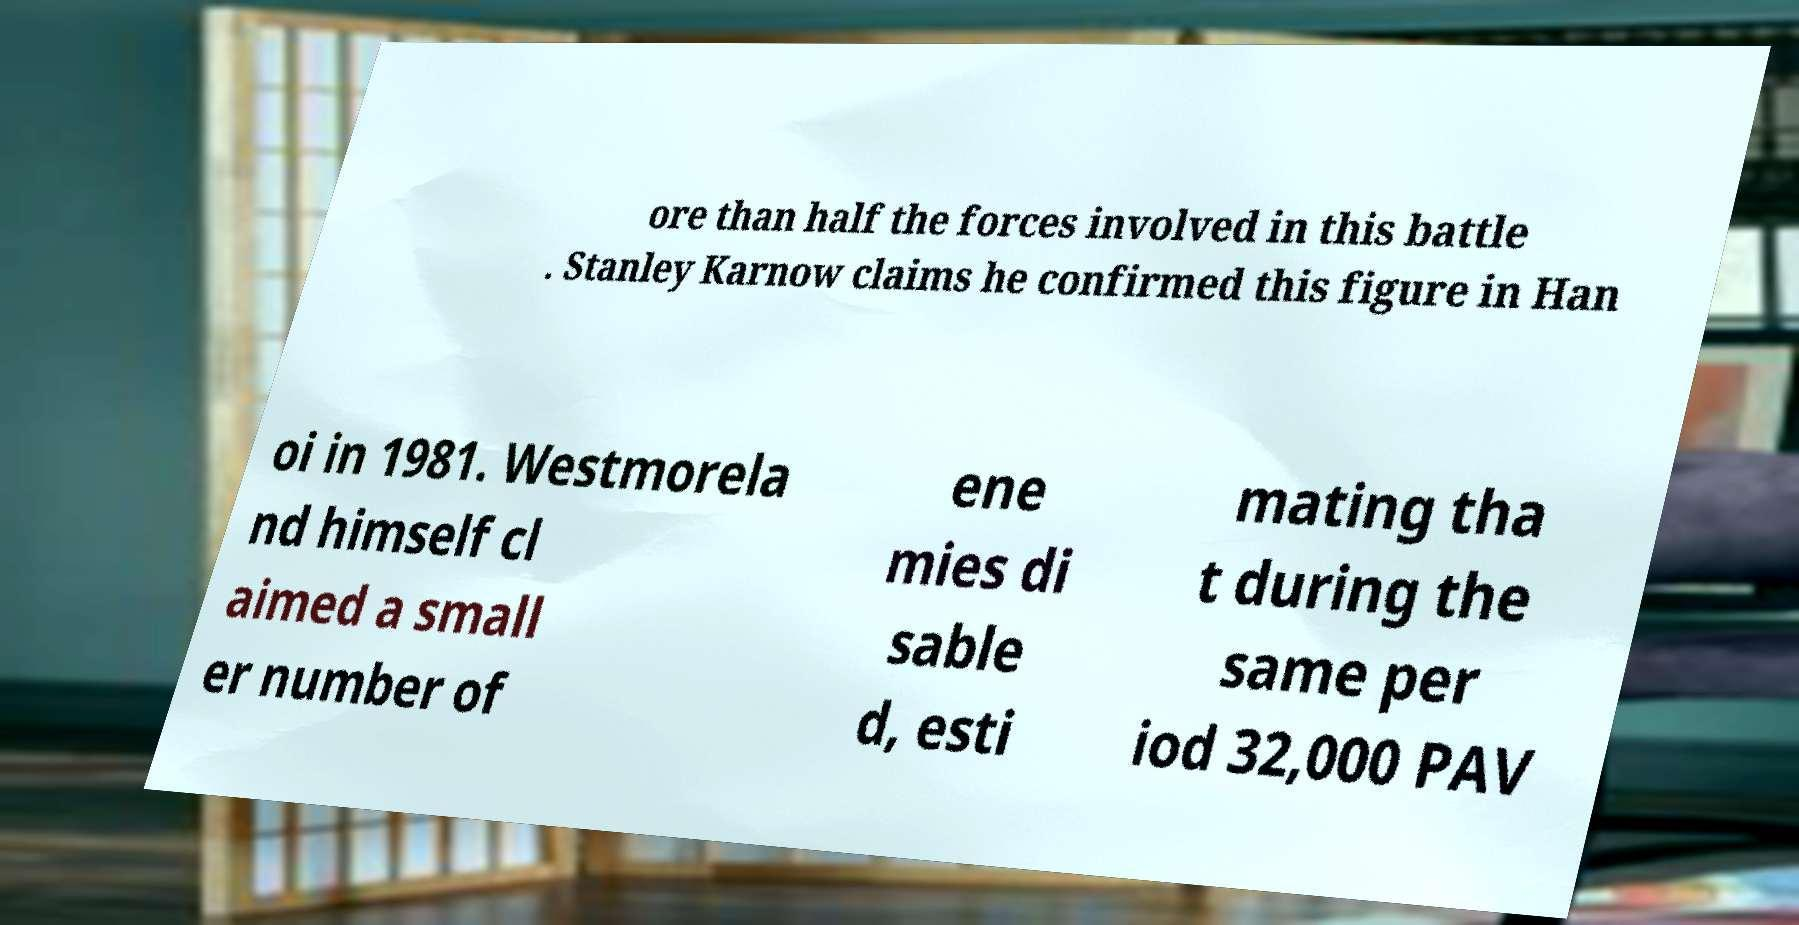Could you extract and type out the text from this image? ore than half the forces involved in this battle . Stanley Karnow claims he confirmed this figure in Han oi in 1981. Westmorela nd himself cl aimed a small er number of ene mies di sable d, esti mating tha t during the same per iod 32,000 PAV 